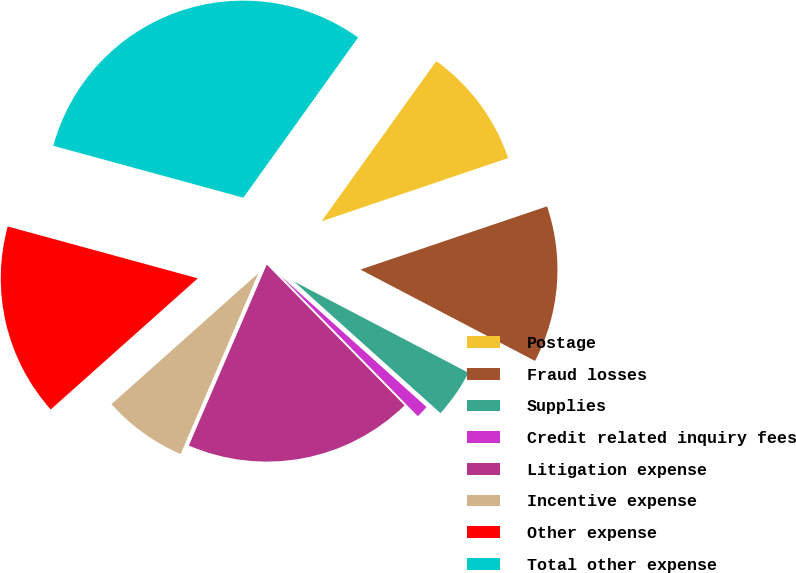Convert chart. <chart><loc_0><loc_0><loc_500><loc_500><pie_chart><fcel>Postage<fcel>Fraud losses<fcel>Supplies<fcel>Credit related inquiry fees<fcel>Litigation expense<fcel>Incentive expense<fcel>Other expense<fcel>Total other expense<nl><fcel>9.91%<fcel>12.87%<fcel>3.98%<fcel>1.02%<fcel>18.8%<fcel>6.94%<fcel>15.83%<fcel>30.65%<nl></chart> 